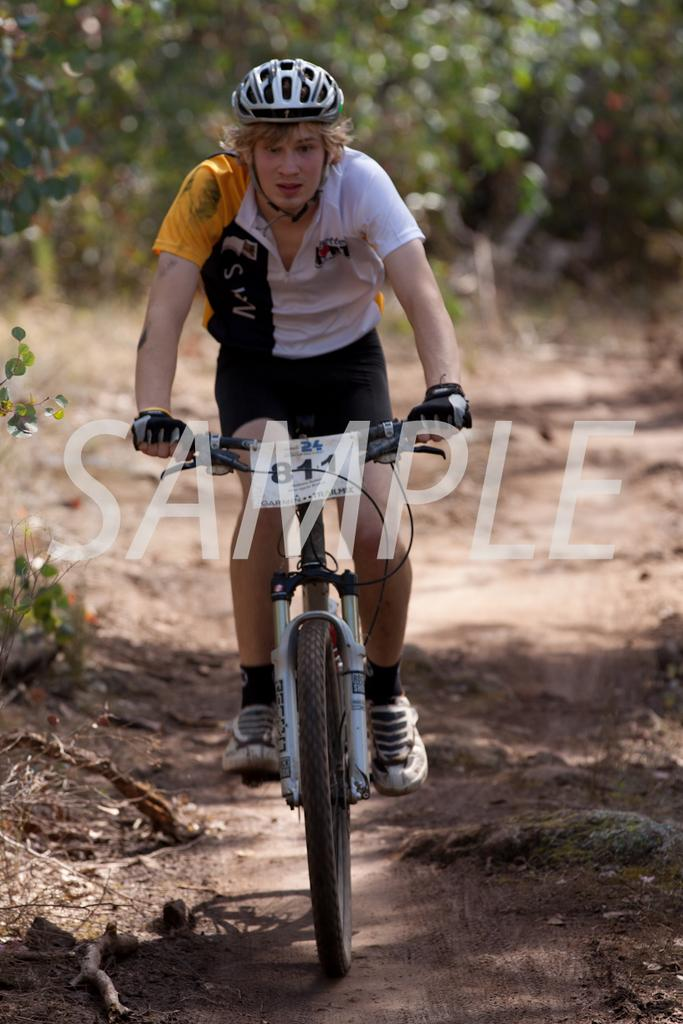Who is the main subject in the image? There is a man in the image. What is the man doing in the image? The man is riding a bicycle. What can be seen in the background of the image? There are trees in the background of the image. What type of terrain is visible in the image? There is land visible in the image, and it has stones on it. What type of vacation is the man enjoying in the image? There is no indication of a vacation in the image; it simply shows a man riding a bicycle. Can you see a mark on the bicycle in the image? There is no mention of a mark on the bicycle in the provided facts, so it cannot be determined from the image. 